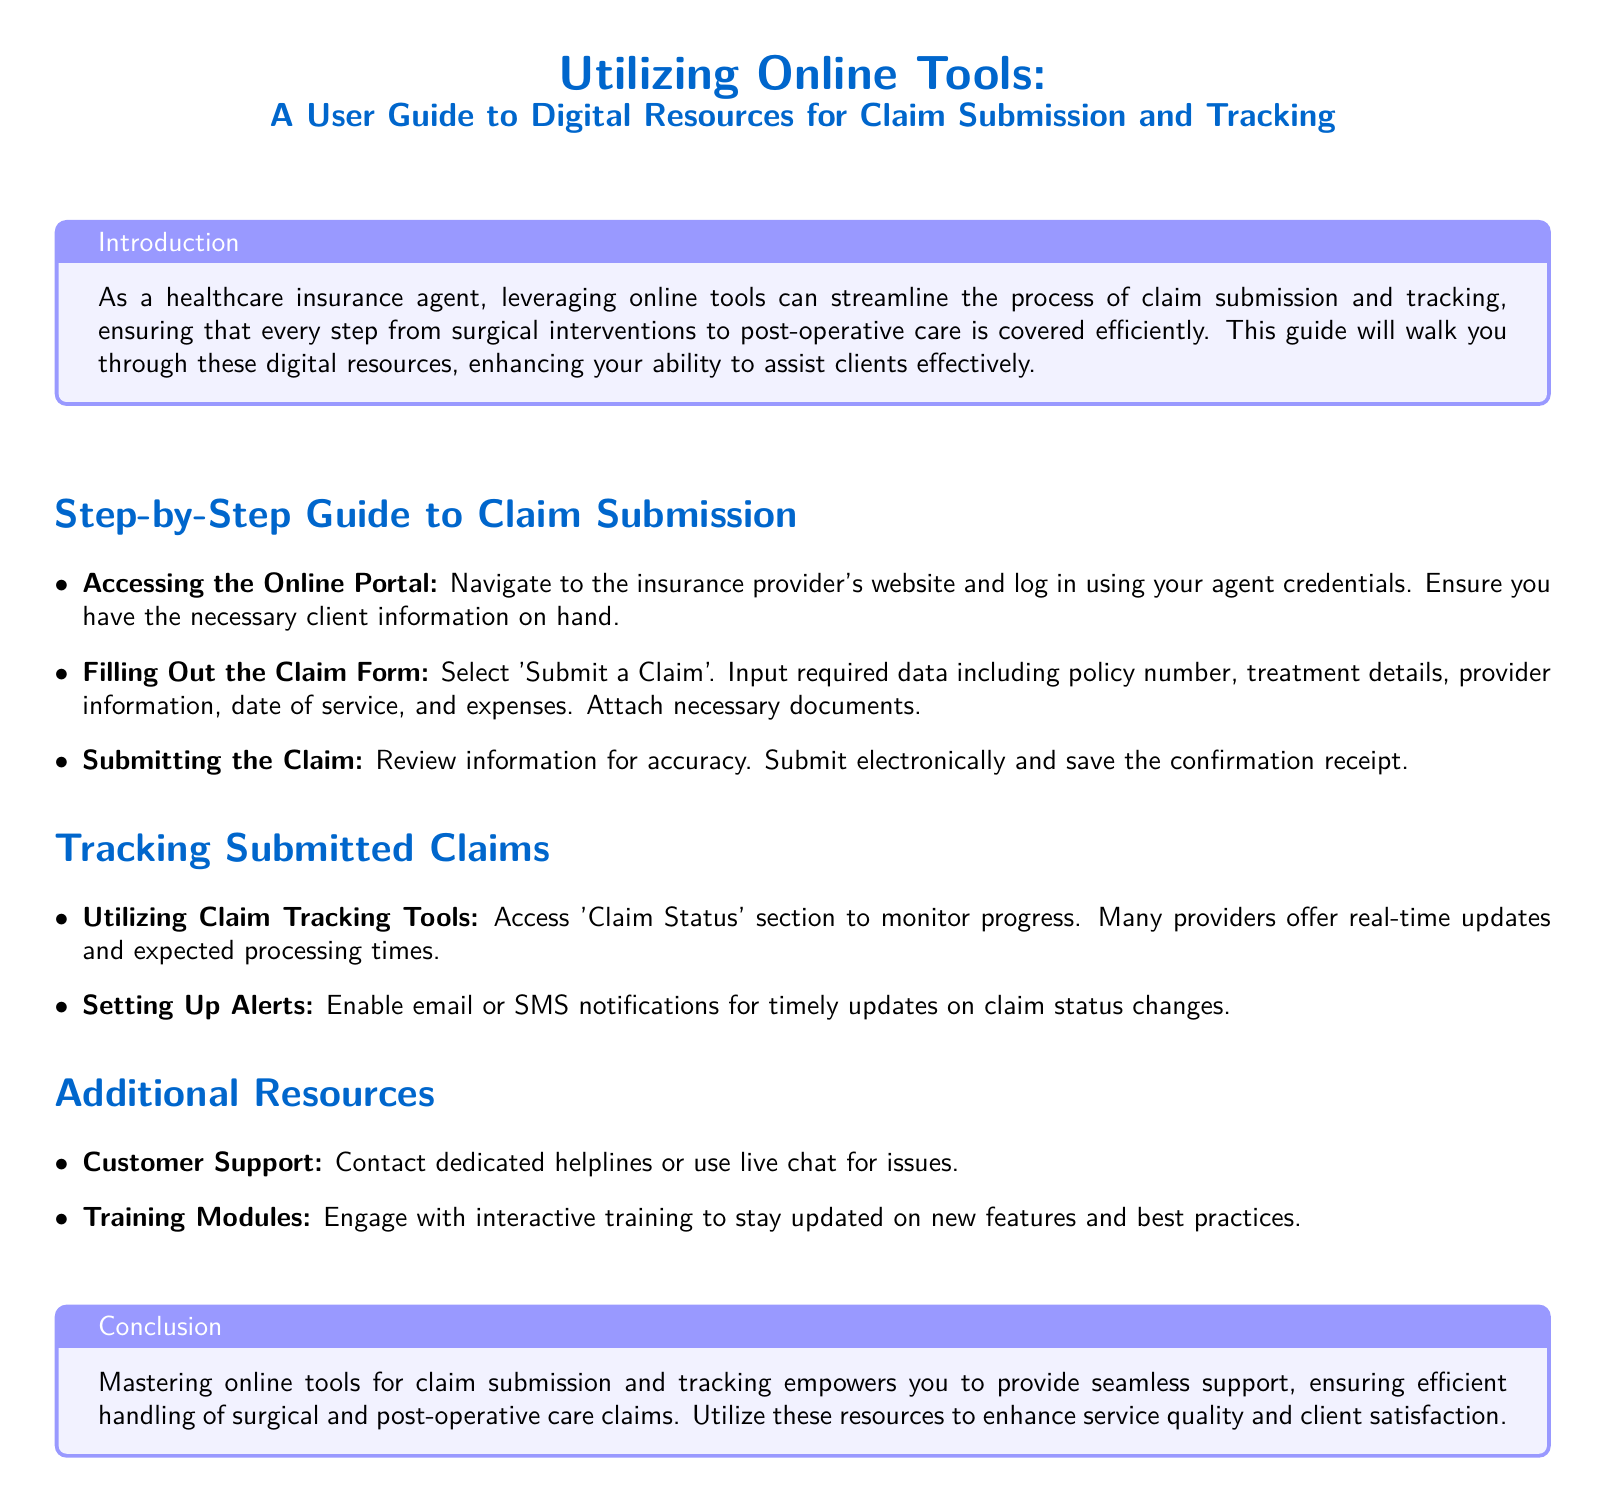what is the title of the document? The title at the top of the document outlines the main subject and purpose, which is guidance on using digital resources for claim submission and tracking.
Answer: Utilizing Online Tools: A User Guide to Digital Resources for Claim Submission and Tracking what section follows the introduction? The document outlines various sections to help users; the introduction is followed by the Step-by-Step Guide to Claim Submission.
Answer: Step-by-Step Guide to Claim Submission how can users track their submitted claims? The document includes specific methods for users to keep track of claims, prominently mentioning a section for monitoring progress.
Answer: Utilizing Claim Tracking Tools what type of notifications can be set up for claim status changes? This detail specifies how users can remain informed about their claims through a particular method outlined in the document.
Answer: Email or SMS notifications what should users do after filling out the claim form? The steps given describe a clear process for claim submission, focusing on post-form completion actions.
Answer: Review information for accuracy which color is used for headings in the document? The document uses specific color themes for visual purposes; the color for headings is mentioned in the formatting details.
Answer: Header Color (RGB: 0,102,204) what type of support is available for users? The section on additional resources provides options for users needing help; support types mentioned include direct communication methods.
Answer: Customer Support how can agents enhance their service quality? The conclusion summarizes the benefits of mastering online tools, implying a clear outcome for effectively assisting clients.
Answer: Utilize these resources 